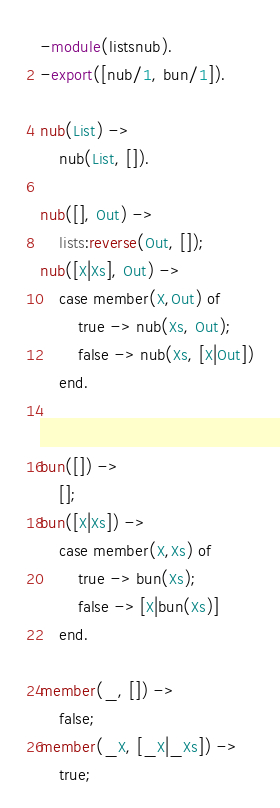Convert code to text. <code><loc_0><loc_0><loc_500><loc_500><_Erlang_>-module(listsnub).
-export([nub/1, bun/1]).

nub(List) ->
    nub(List, []).

nub([], Out) ->
    lists:reverse(Out, []);
nub([X|Xs], Out) ->
    case member(X,Out) of
        true -> nub(Xs, Out);
        false -> nub(Xs, [X|Out])
    end.


bun([]) ->
    [];
bun([X|Xs]) ->
    case member(X,Xs) of
        true -> bun(Xs);
        false -> [X|bun(Xs)]
    end.

member(_, []) ->
    false;
member(_X, [_X|_Xs]) ->
    true;</code> 